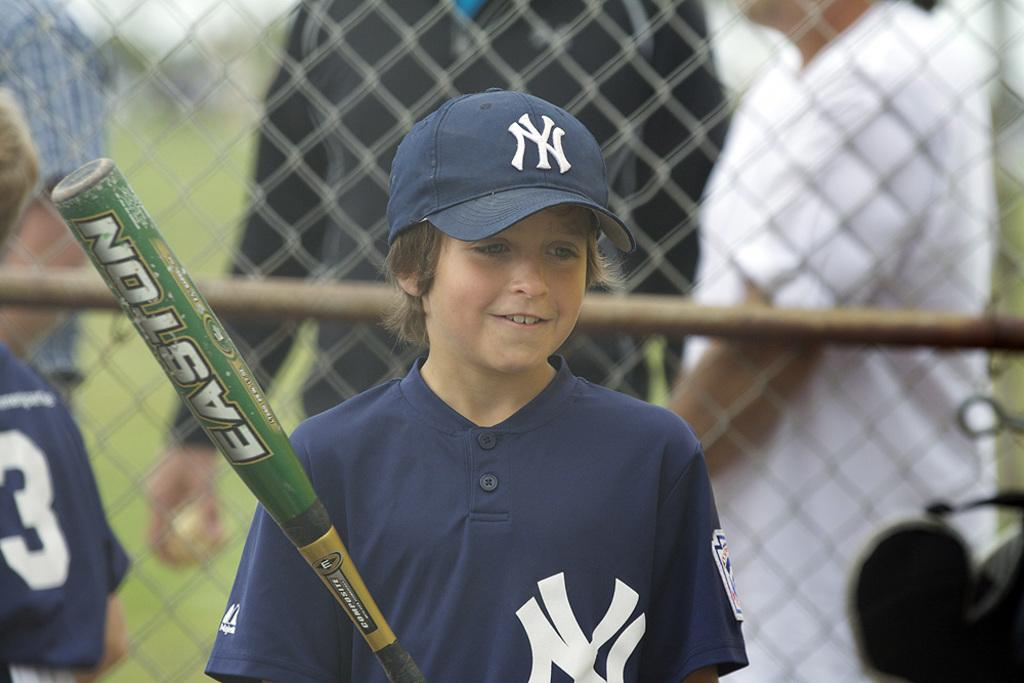<image>
Write a terse but informative summary of the picture. A young boy in a NY Yankees cap holds an Easton bat in his hand. 